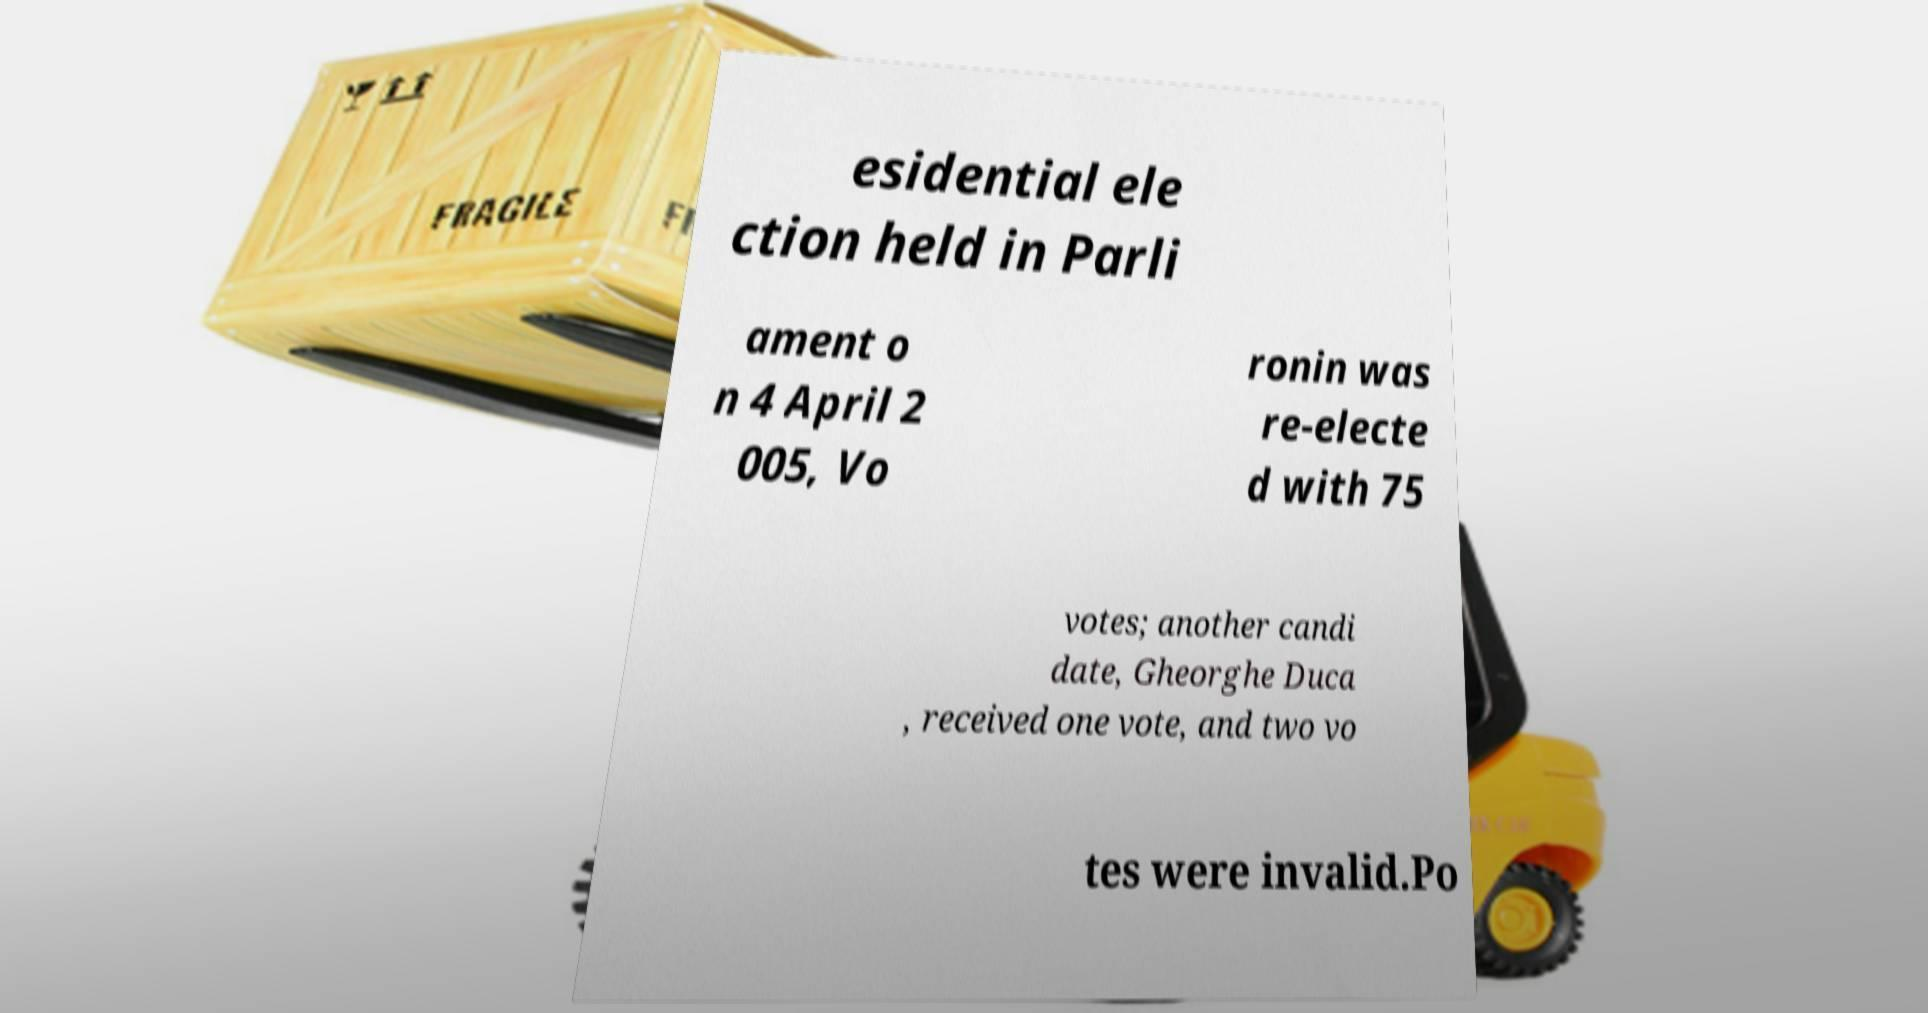Can you read and provide the text displayed in the image?This photo seems to have some interesting text. Can you extract and type it out for me? esidential ele ction held in Parli ament o n 4 April 2 005, Vo ronin was re-electe d with 75 votes; another candi date, Gheorghe Duca , received one vote, and two vo tes were invalid.Po 